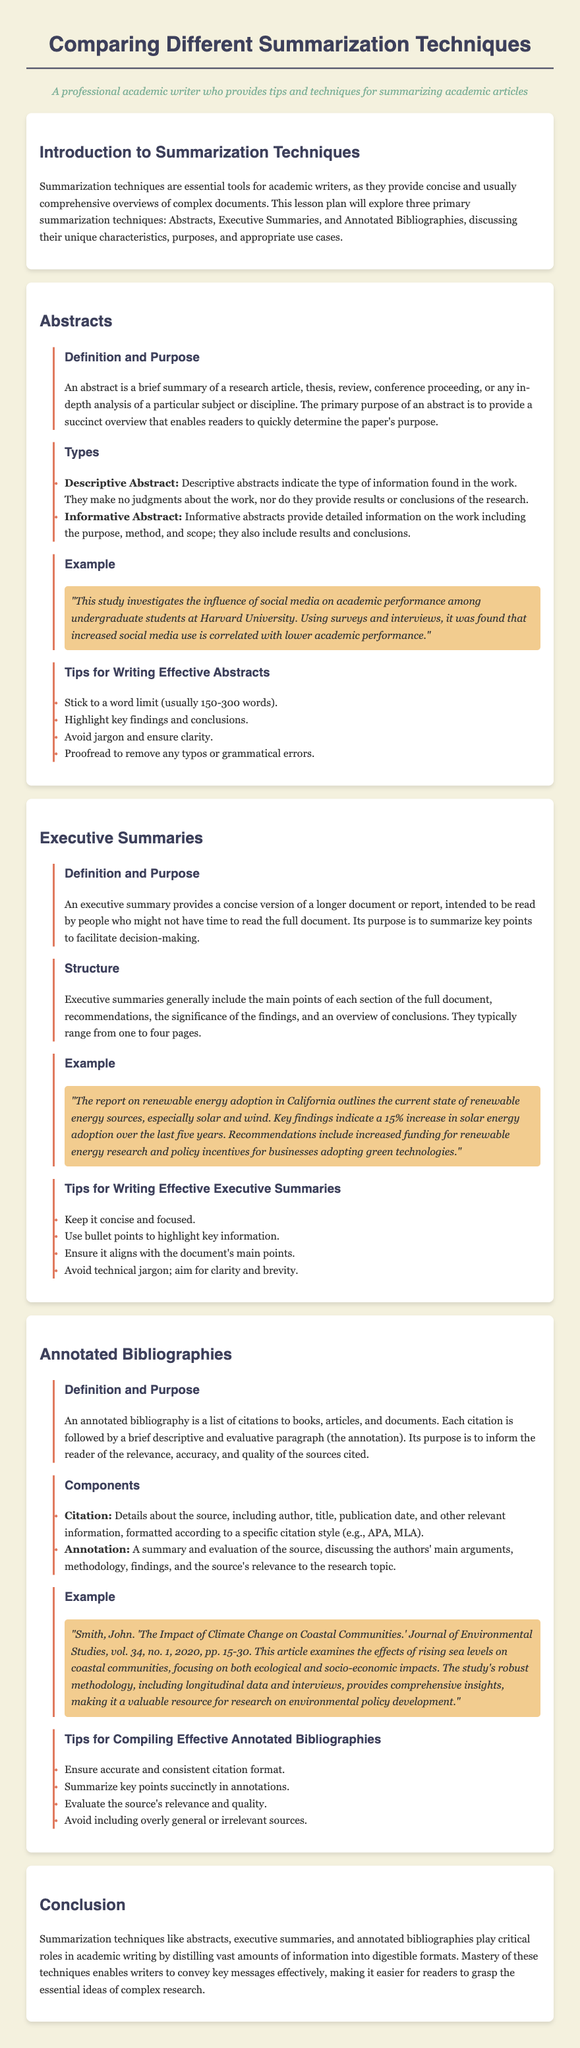What is the main focus of the lesson plan? The lesson plan focuses on summarization techniques in academic writing, specifically Abstracts, Executive Summaries, and Annotated Bibliographies.
Answer: Summarization techniques What type of abstract provides detailed information including results and conclusions? The types of abstracts are Descriptive and Informative. Informative abstracts provide detailed information including results and conclusions.
Answer: Informative Abstract What is the typical word limit for effective abstracts? The document advises a word limit of usually 150-300 words for effective abstracts.
Answer: 150-300 words How many pages can an executive summary typically range from? Executive summaries typically range from one to four pages.
Answer: One to four pages What is the main purpose of an annotated bibliography? The purpose of an annotated bibliography is to inform the reader of the relevance, accuracy, and quality of the sources cited.
Answer: Relevance, accuracy, and quality What are the two main components of an annotated bibliography? The two main components are Citation and Annotation.
Answer: Citation and Annotation List one tip for writing effective executive summaries. The document provides several tips for writing effective executive summaries; one is to keep it concise and focused.
Answer: Concise and focused Which example demonstrates an executive summary? An example of an executive summary provided discusses renewable energy adoption in California.
Answer: Renewable energy adoption in California What is the purpose of abstracts in academic writing? The primary purpose of an abstract is to provide a succinct overview that enables readers to quickly determine the paper's purpose.
Answer: Succinct overview 